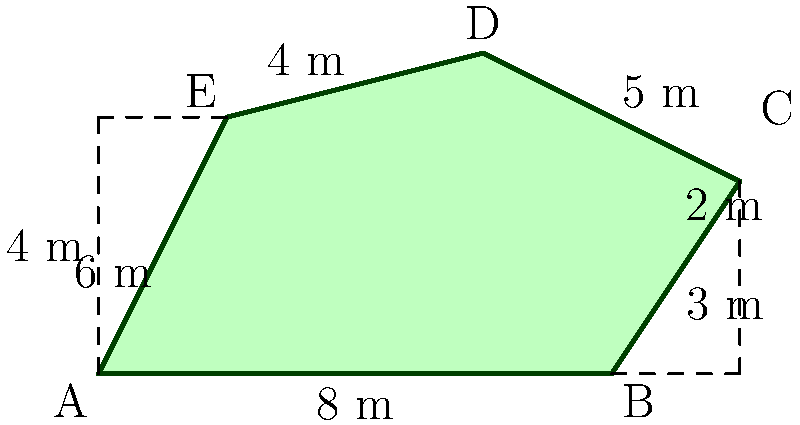As an eco-conscious graphic designer, you're planning to install a custom-shaped solar panel array on your studio roof to power your battery-operated equipment. The array is an irregular pentagon, as shown in the diagram. Calculate the total surface area of the solar panel array in square meters. To calculate the surface area of this irregular pentagon, we can divide it into simpler shapes and sum their areas. Let's break it down step by step:

1. Divide the pentagon into a rectangle and two right triangles.

2. Calculate the area of the rectangle:
   Length = 8 m, Width = 4 m
   Area of rectangle = $8 \times 4 = 32$ m²

3. Calculate the area of the right triangle on the left:
   Base = 2 m, Height = 4 m
   Area of left triangle = $\frac{1}{2} \times 2 \times 4 = 4$ m²

4. Calculate the area of the right triangle on the right:
   Base = 2 m, Height = 3 m
   Area of right triangle = $\frac{1}{2} \times 2 \times 3 = 3$ m²

5. Sum up all the areas:
   Total Area = Rectangle + Left Triangle + Right Triangle
   Total Area = $32 + 4 + 3 = 39$ m²

Therefore, the total surface area of the solar panel array is 39 square meters.
Answer: 39 m² 